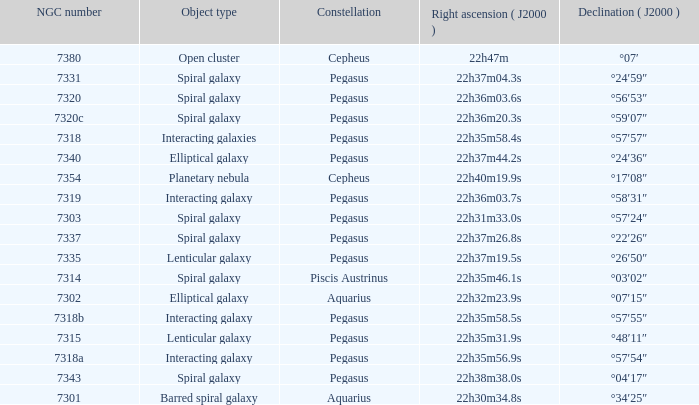What is Pegasus' right ascension with a 7318a NGC? 22h35m56.9s. 